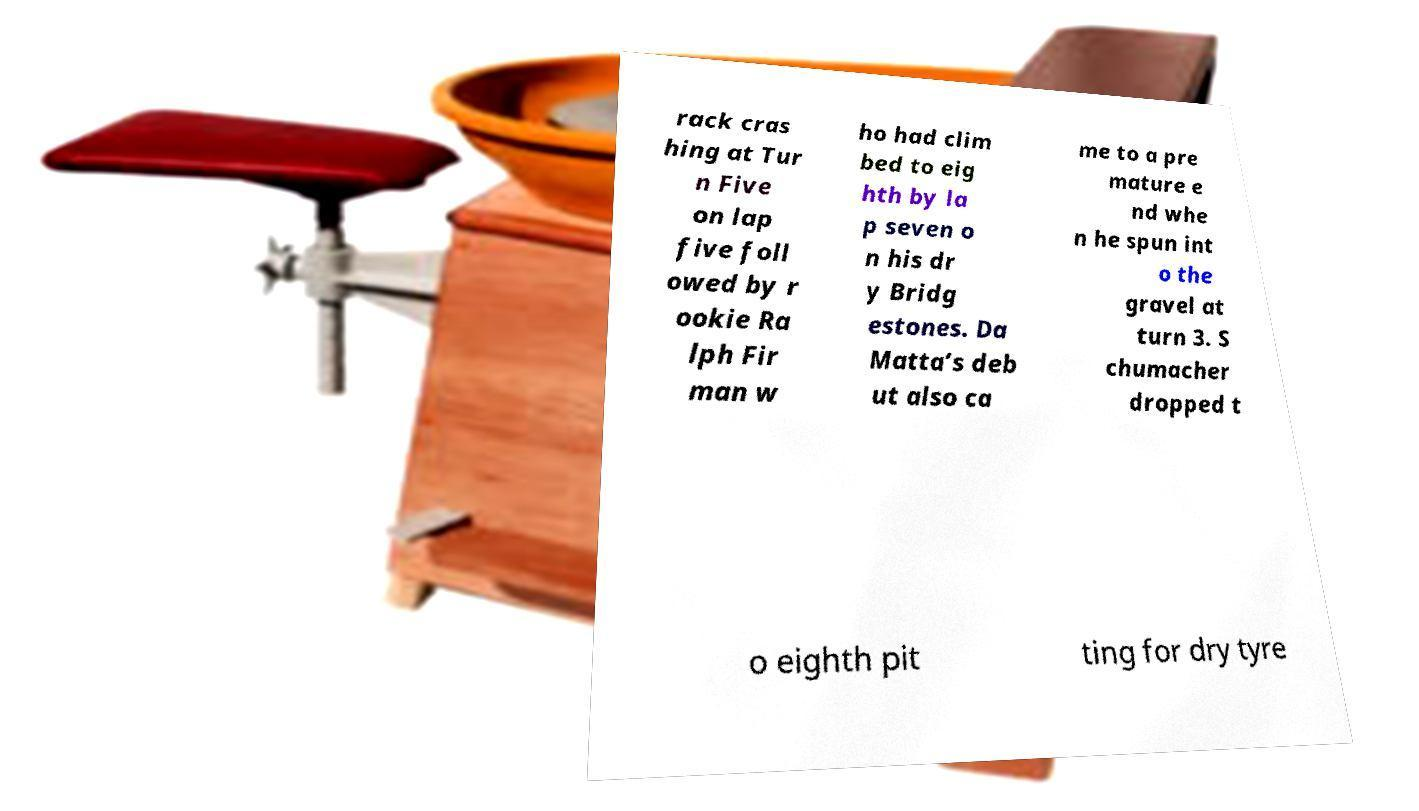Can you read and provide the text displayed in the image?This photo seems to have some interesting text. Can you extract and type it out for me? rack cras hing at Tur n Five on lap five foll owed by r ookie Ra lph Fir man w ho had clim bed to eig hth by la p seven o n his dr y Bridg estones. Da Matta’s deb ut also ca me to a pre mature e nd whe n he spun int o the gravel at turn 3. S chumacher dropped t o eighth pit ting for dry tyre 